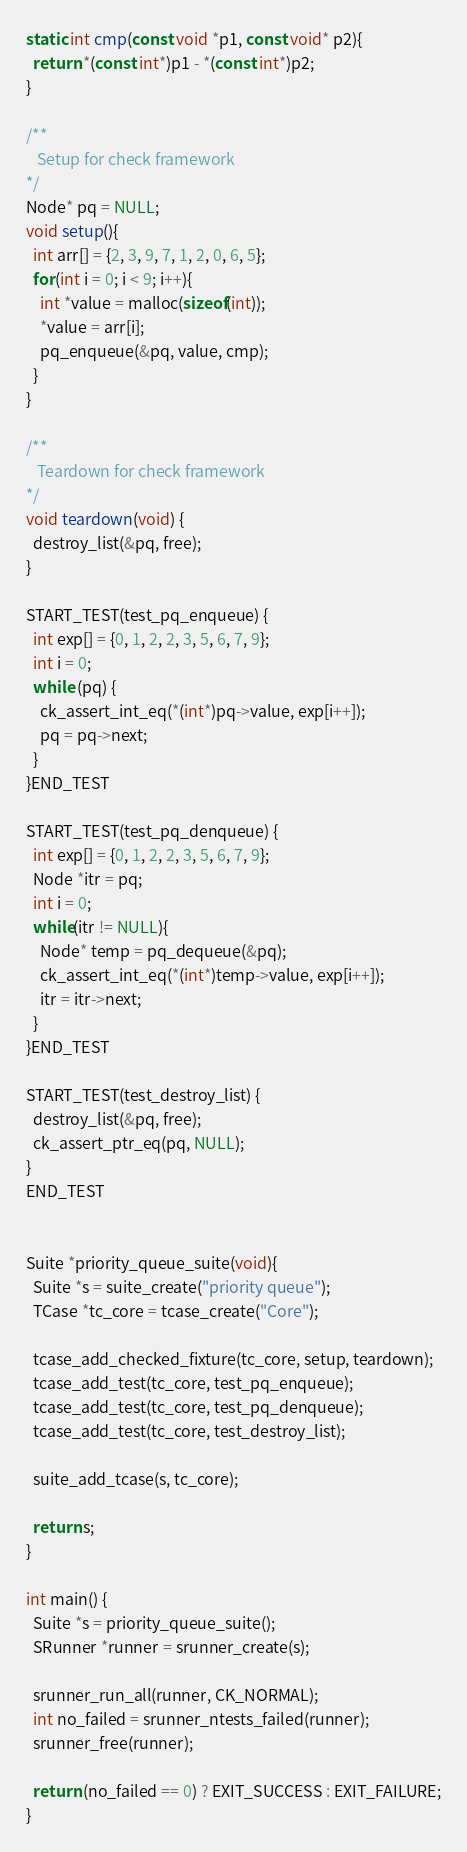Convert code to text. <code><loc_0><loc_0><loc_500><loc_500><_C_>static int cmp(const void *p1, const void* p2){
  return *(const int*)p1 - *(const int*)p2;
}

/**
   Setup for check framework
*/
Node* pq = NULL;
void setup(){
  int arr[] = {2, 3, 9, 7, 1, 2, 0, 6, 5};
  for(int i = 0; i < 9; i++){
    int *value = malloc(sizeof(int));
    *value = arr[i];
    pq_enqueue(&pq, value, cmp);
  }
}

/**
   Teardown for check framework
*/
void teardown(void) {
  destroy_list(&pq, free);
}

START_TEST(test_pq_enqueue) {
  int exp[] = {0, 1, 2, 2, 3, 5, 6, 7, 9};  
  int i = 0;
  while (pq) {
    ck_assert_int_eq(*(int*)pq->value, exp[i++]);
    pq = pq->next;
  }
}END_TEST

START_TEST(test_pq_denqueue) {
  int exp[] = {0, 1, 2, 2, 3, 5, 6, 7, 9};
  Node *itr = pq;
  int i = 0;
  while(itr != NULL){
    Node* temp = pq_dequeue(&pq);
    ck_assert_int_eq(*(int*)temp->value, exp[i++]);
    itr = itr->next;
  }
}END_TEST

START_TEST(test_destroy_list) {
  destroy_list(&pq, free);
  ck_assert_ptr_eq(pq, NULL);
}
END_TEST


Suite *priority_queue_suite(void){
  Suite *s = suite_create("priority queue");
  TCase *tc_core = tcase_create("Core");
  
  tcase_add_checked_fixture(tc_core, setup, teardown);
  tcase_add_test(tc_core, test_pq_enqueue);
  tcase_add_test(tc_core, test_pq_denqueue);
  tcase_add_test(tc_core, test_destroy_list);
  
  suite_add_tcase(s, tc_core);

  return s;
}

int main() {
  Suite *s = priority_queue_suite();
  SRunner *runner = srunner_create(s);

  srunner_run_all(runner, CK_NORMAL);
  int no_failed = srunner_ntests_failed(runner);
  srunner_free(runner);

  return (no_failed == 0) ? EXIT_SUCCESS : EXIT_FAILURE;
}
</code> 